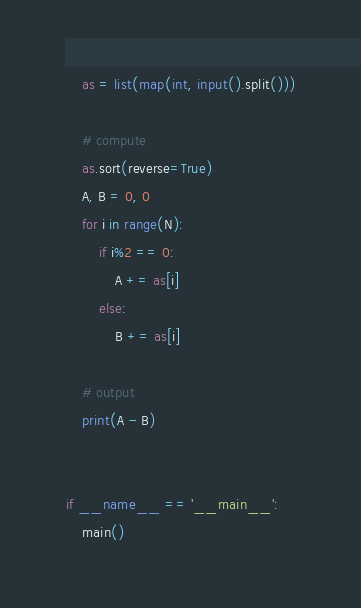Convert code to text. <code><loc_0><loc_0><loc_500><loc_500><_Python_>    as = list(map(int, input().split()))

    # compute
    as.sort(reverse=True)
    A, B = 0, 0
    for i in range(N):
        if i%2 == 0:
            A += as[i]
        else:
            B += as[i]

    # output
    print(A - B)


if __name__ == '__main__':
    main()
</code> 